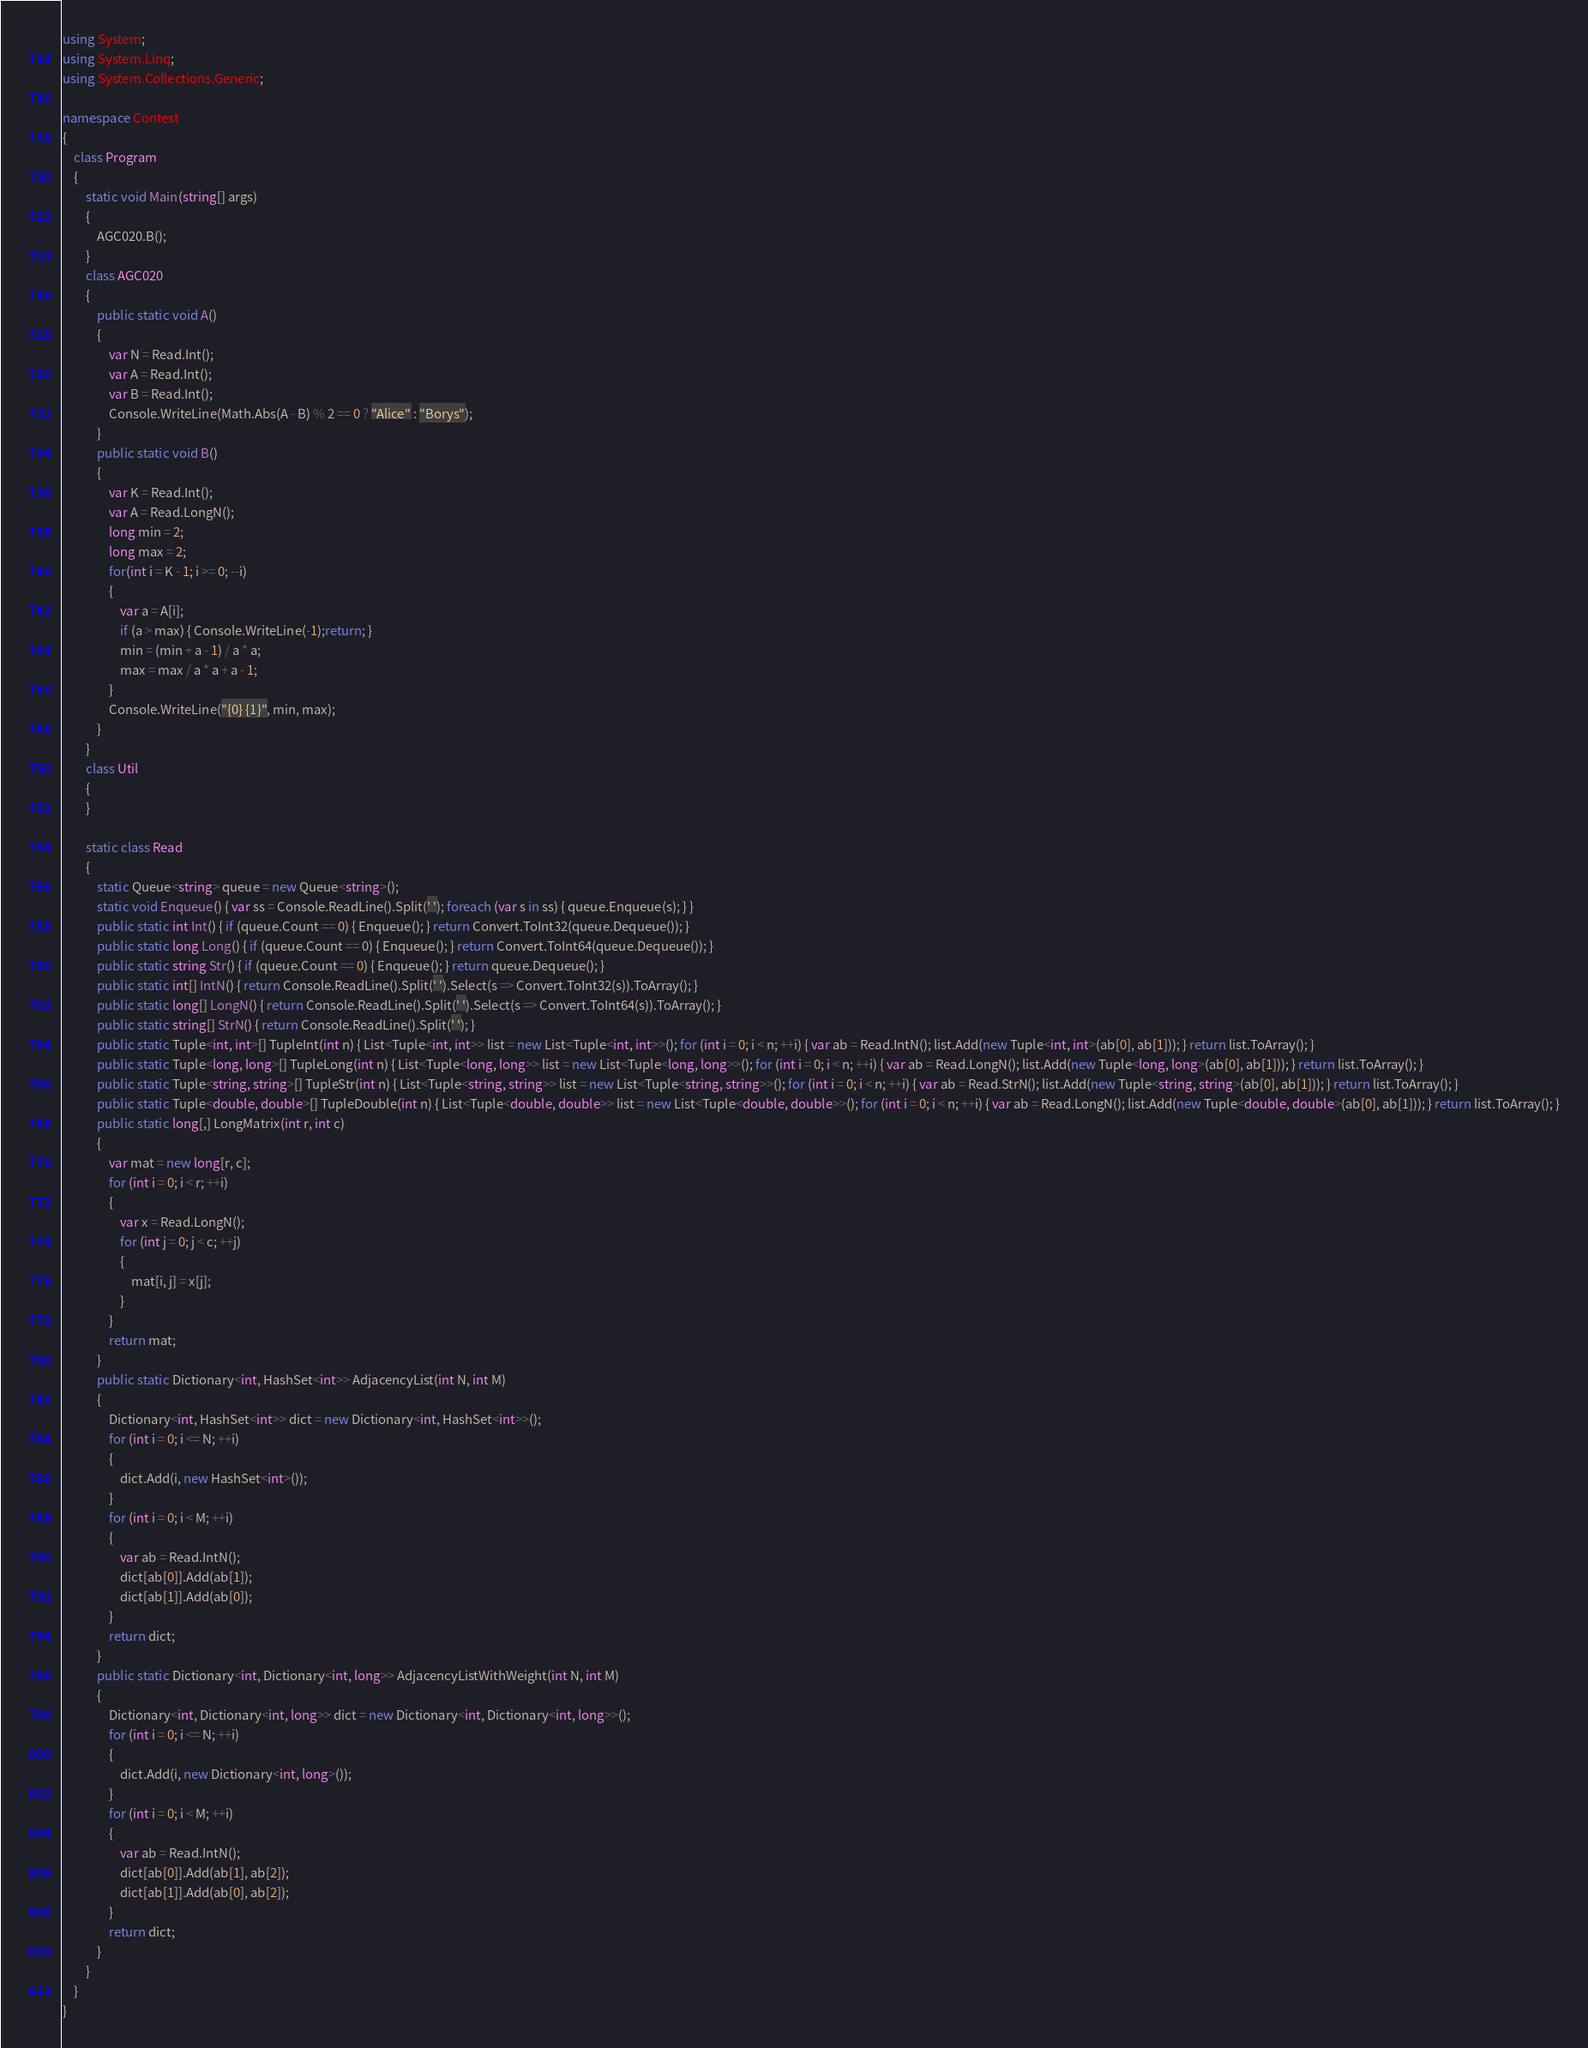Convert code to text. <code><loc_0><loc_0><loc_500><loc_500><_C#_>using System;
using System.Linq;
using System.Collections.Generic;

namespace Contest
{
    class Program
    {
        static void Main(string[] args)
        {
            AGC020.B();
        }
        class AGC020
        {
            public static void A()
            {
                var N = Read.Int();
                var A = Read.Int();
                var B = Read.Int();
                Console.WriteLine(Math.Abs(A - B) % 2 == 0 ? "Alice" : "Borys");
            }
            public static void B()
            {
                var K = Read.Int();
                var A = Read.LongN();
                long min = 2;
                long max = 2;
                for(int i = K - 1; i >= 0; --i)
                {
                    var a = A[i];
                    if (a > max) { Console.WriteLine(-1);return; }
                    min = (min + a - 1) / a * a;
                    max = max / a * a + a - 1;
                }
                Console.WriteLine("{0} {1}", min, max);
            }
        }
        class Util
        {
        }

        static class Read
        {
            static Queue<string> queue = new Queue<string>();
            static void Enqueue() { var ss = Console.ReadLine().Split(' '); foreach (var s in ss) { queue.Enqueue(s); } }
            public static int Int() { if (queue.Count == 0) { Enqueue(); } return Convert.ToInt32(queue.Dequeue()); }
            public static long Long() { if (queue.Count == 0) { Enqueue(); } return Convert.ToInt64(queue.Dequeue()); }
            public static string Str() { if (queue.Count == 0) { Enqueue(); } return queue.Dequeue(); }
            public static int[] IntN() { return Console.ReadLine().Split(' ').Select(s => Convert.ToInt32(s)).ToArray(); }
            public static long[] LongN() { return Console.ReadLine().Split(' ').Select(s => Convert.ToInt64(s)).ToArray(); }
            public static string[] StrN() { return Console.ReadLine().Split(' '); }
            public static Tuple<int, int>[] TupleInt(int n) { List<Tuple<int, int>> list = new List<Tuple<int, int>>(); for (int i = 0; i < n; ++i) { var ab = Read.IntN(); list.Add(new Tuple<int, int>(ab[0], ab[1])); } return list.ToArray(); }
            public static Tuple<long, long>[] TupleLong(int n) { List<Tuple<long, long>> list = new List<Tuple<long, long>>(); for (int i = 0; i < n; ++i) { var ab = Read.LongN(); list.Add(new Tuple<long, long>(ab[0], ab[1])); } return list.ToArray(); }
            public static Tuple<string, string>[] TupleStr(int n) { List<Tuple<string, string>> list = new List<Tuple<string, string>>(); for (int i = 0; i < n; ++i) { var ab = Read.StrN(); list.Add(new Tuple<string, string>(ab[0], ab[1])); } return list.ToArray(); }
            public static Tuple<double, double>[] TupleDouble(int n) { List<Tuple<double, double>> list = new List<Tuple<double, double>>(); for (int i = 0; i < n; ++i) { var ab = Read.LongN(); list.Add(new Tuple<double, double>(ab[0], ab[1])); } return list.ToArray(); }
            public static long[,] LongMatrix(int r, int c)
            {
                var mat = new long[r, c];
                for (int i = 0; i < r; ++i)
                {
                    var x = Read.LongN();
                    for (int j = 0; j < c; ++j)
                    {
                        mat[i, j] = x[j];
                    }
                }
                return mat;
            }
            public static Dictionary<int, HashSet<int>> AdjacencyList(int N, int M)
            {
                Dictionary<int, HashSet<int>> dict = new Dictionary<int, HashSet<int>>();
                for (int i = 0; i <= N; ++i)
                {
                    dict.Add(i, new HashSet<int>());
                }
                for (int i = 0; i < M; ++i)
                {
                    var ab = Read.IntN();
                    dict[ab[0]].Add(ab[1]);
                    dict[ab[1]].Add(ab[0]);
                }
                return dict;
            }
            public static Dictionary<int, Dictionary<int, long>> AdjacencyListWithWeight(int N, int M)
            {
                Dictionary<int, Dictionary<int, long>> dict = new Dictionary<int, Dictionary<int, long>>();
                for (int i = 0; i <= N; ++i)
                {
                    dict.Add(i, new Dictionary<int, long>());
                }
                for (int i = 0; i < M; ++i)
                {
                    var ab = Read.IntN();
                    dict[ab[0]].Add(ab[1], ab[2]);
                    dict[ab[1]].Add(ab[0], ab[2]);
                }
                return dict;
            }
        }
    }
}
</code> 